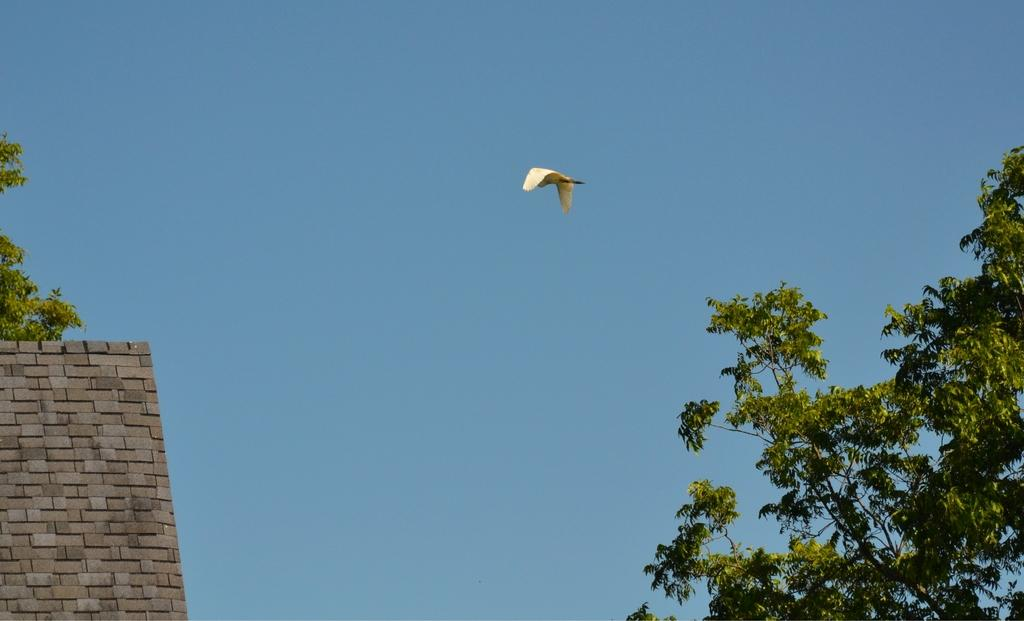What is the main subject of the image? There is a bird flying in the image. What can be seen in the background of the image? The sky is visible in the background of the image. What type of vegetation is present in the image? There are trees in the image. What architectural feature can be seen in the image? There is a wall in the image. What type of pies can be seen hanging from the branches of the trees in the image? There are no pies present in the image; it features a bird flying and trees in the background. Is the bird wearing a collar in the image? There is no indication that the bird is wearing a collar in the image. 